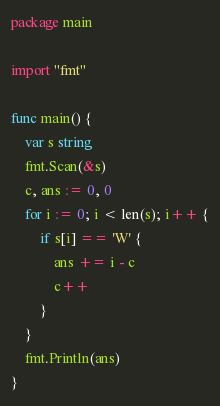Convert code to text. <code><loc_0><loc_0><loc_500><loc_500><_Go_>package main

import "fmt"

func main() {
	var s string
	fmt.Scan(&s)
	c, ans := 0, 0
	for i := 0; i < len(s); i++ {
		if s[i] == 'W' {
			ans += i - c
			c++
		}
	}
	fmt.Println(ans)
}
</code> 